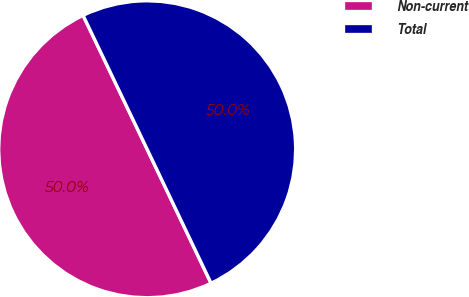<chart> <loc_0><loc_0><loc_500><loc_500><pie_chart><fcel>Non-current<fcel>Total<nl><fcel>49.98%<fcel>50.02%<nl></chart> 